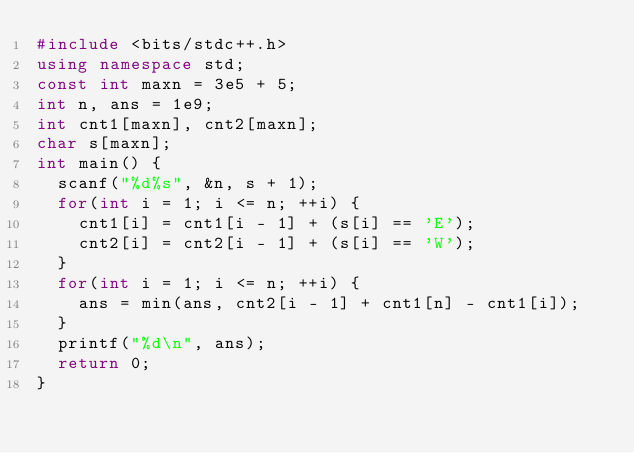<code> <loc_0><loc_0><loc_500><loc_500><_C++_>#include <bits/stdc++.h>
using namespace std;
const int maxn = 3e5 + 5;
int n, ans = 1e9;
int cnt1[maxn], cnt2[maxn];
char s[maxn];
int main() {
	scanf("%d%s", &n, s + 1);
	for(int i = 1; i <= n; ++i) {
		cnt1[i] = cnt1[i - 1] + (s[i] == 'E');
		cnt2[i] = cnt2[i - 1] + (s[i] == 'W');
	}
	for(int i = 1; i <= n; ++i) {
		ans = min(ans, cnt2[i - 1] + cnt1[n] - cnt1[i]);
	}
	printf("%d\n", ans);
	return 0;
}</code> 